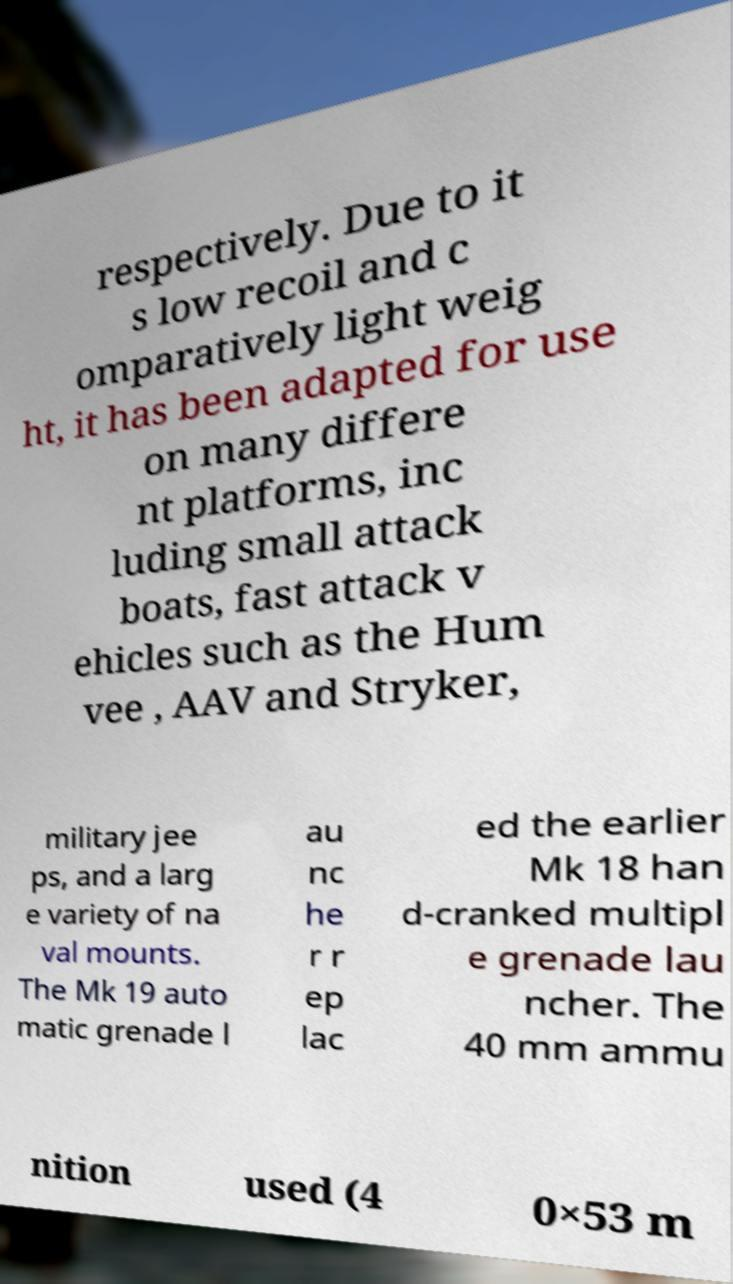Can you read and provide the text displayed in the image?This photo seems to have some interesting text. Can you extract and type it out for me? respectively. Due to it s low recoil and c omparatively light weig ht, it has been adapted for use on many differe nt platforms, inc luding small attack boats, fast attack v ehicles such as the Hum vee , AAV and Stryker, military jee ps, and a larg e variety of na val mounts. The Mk 19 auto matic grenade l au nc he r r ep lac ed the earlier Mk 18 han d-cranked multipl e grenade lau ncher. The 40 mm ammu nition used (4 0×53 m 